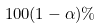<formula> <loc_0><loc_0><loc_500><loc_500>1 0 0 ( 1 - \alpha ) \%</formula> 